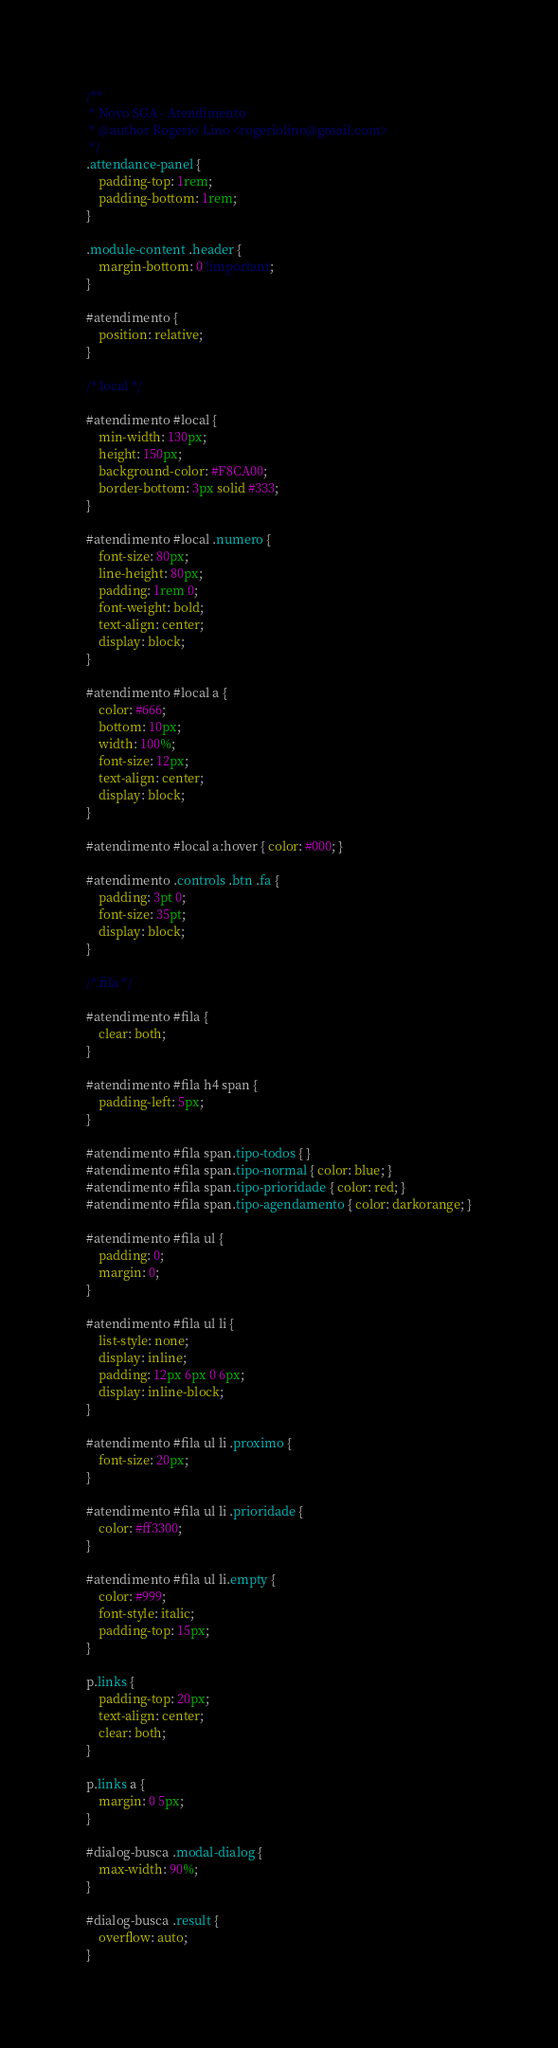Convert code to text. <code><loc_0><loc_0><loc_500><loc_500><_CSS_>/**
 * Novo SGA - Atendimento
 * @author Rogerio Lino <rogeriolino@gmail.com>
 */
.attendance-panel {
    padding-top: 1rem;
    padding-bottom: 1rem;
}

.module-content .header {
    margin-bottom: 0 !important;
}

#atendimento {
    position: relative;
}

/* local */

#atendimento #local {
    min-width: 130px;
    height: 150px;
    background-color: #F8CA00;
    border-bottom: 3px solid #333;
}

#atendimento #local .numero {
    font-size: 80px;
    line-height: 80px;
    padding: 1rem 0;
    font-weight: bold;
    text-align: center;
    display: block;
}

#atendimento #local a {
    color: #666;
    bottom: 10px;
    width: 100%;
    font-size: 12px;
    text-align: center;
    display: block;
}

#atendimento #local a:hover { color: #000; }

#atendimento .controls .btn .fa {
    padding: 3pt 0;
    font-size: 35pt;
    display: block;
}

/* fila */

#atendimento #fila {
    clear: both;
}

#atendimento #fila h4 span {
    padding-left: 5px;
}

#atendimento #fila span.tipo-todos { }
#atendimento #fila span.tipo-normal { color: blue; }
#atendimento #fila span.tipo-prioridade { color: red; }
#atendimento #fila span.tipo-agendamento { color: darkorange; }

#atendimento #fila ul {
    padding: 0;
    margin: 0;
}

#atendimento #fila ul li {
    list-style: none;
    display: inline;
    padding: 12px 6px 0 6px;
    display: inline-block;
}

#atendimento #fila ul li .proximo {
    font-size: 20px;
}

#atendimento #fila ul li .prioridade {
    color: #ff3300;
}

#atendimento #fila ul li.empty {
    color: #999;
    font-style: italic;
    padding-top: 15px;
}

p.links {
    padding-top: 20px;
    text-align: center;
    clear: both;
}

p.links a {
    margin: 0 5px;
}

#dialog-busca .modal-dialog {
    max-width: 90%;
}

#dialog-busca .result {
    overflow: auto;
}
</code> 